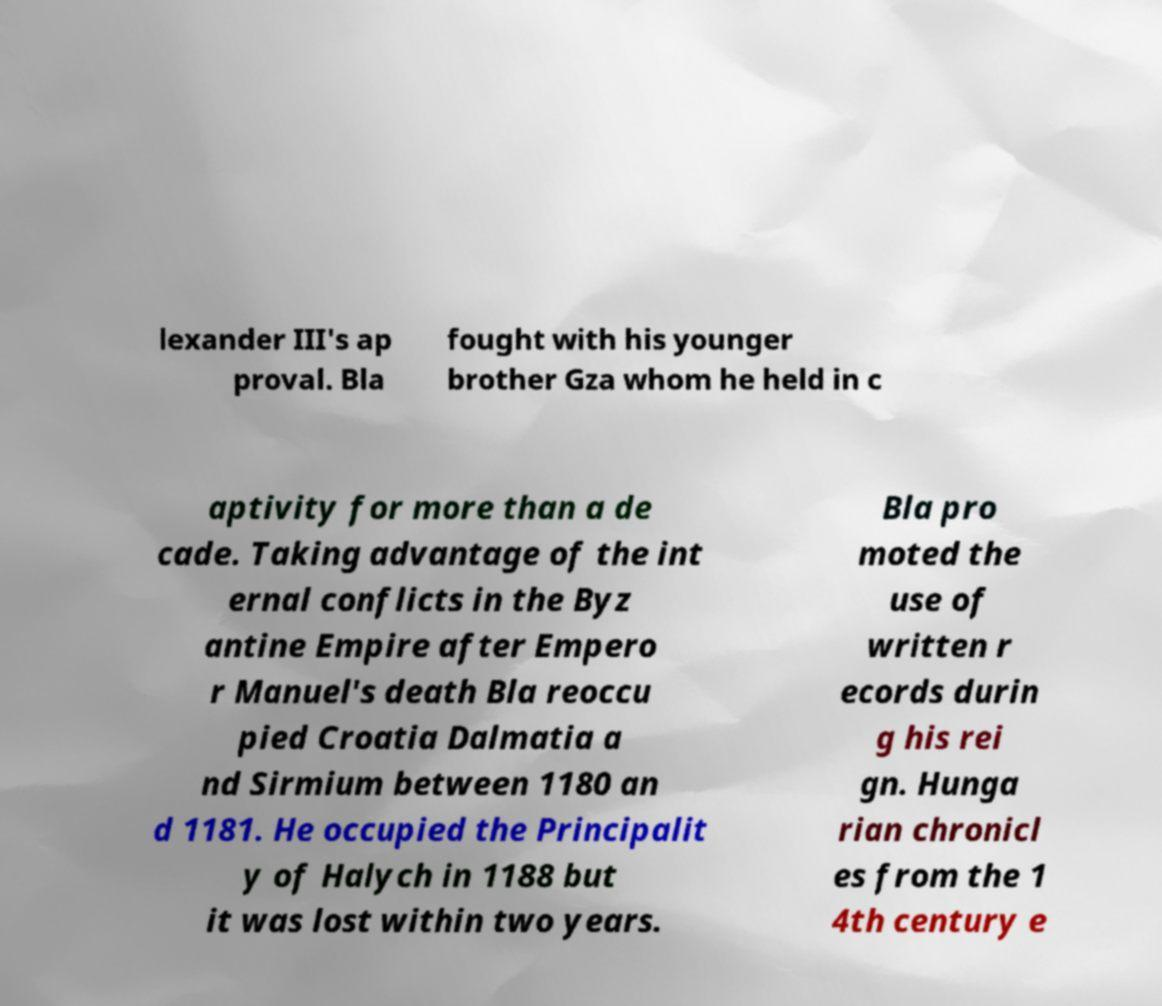Please identify and transcribe the text found in this image. lexander III's ap proval. Bla fought with his younger brother Gza whom he held in c aptivity for more than a de cade. Taking advantage of the int ernal conflicts in the Byz antine Empire after Empero r Manuel's death Bla reoccu pied Croatia Dalmatia a nd Sirmium between 1180 an d 1181. He occupied the Principalit y of Halych in 1188 but it was lost within two years. Bla pro moted the use of written r ecords durin g his rei gn. Hunga rian chronicl es from the 1 4th century e 